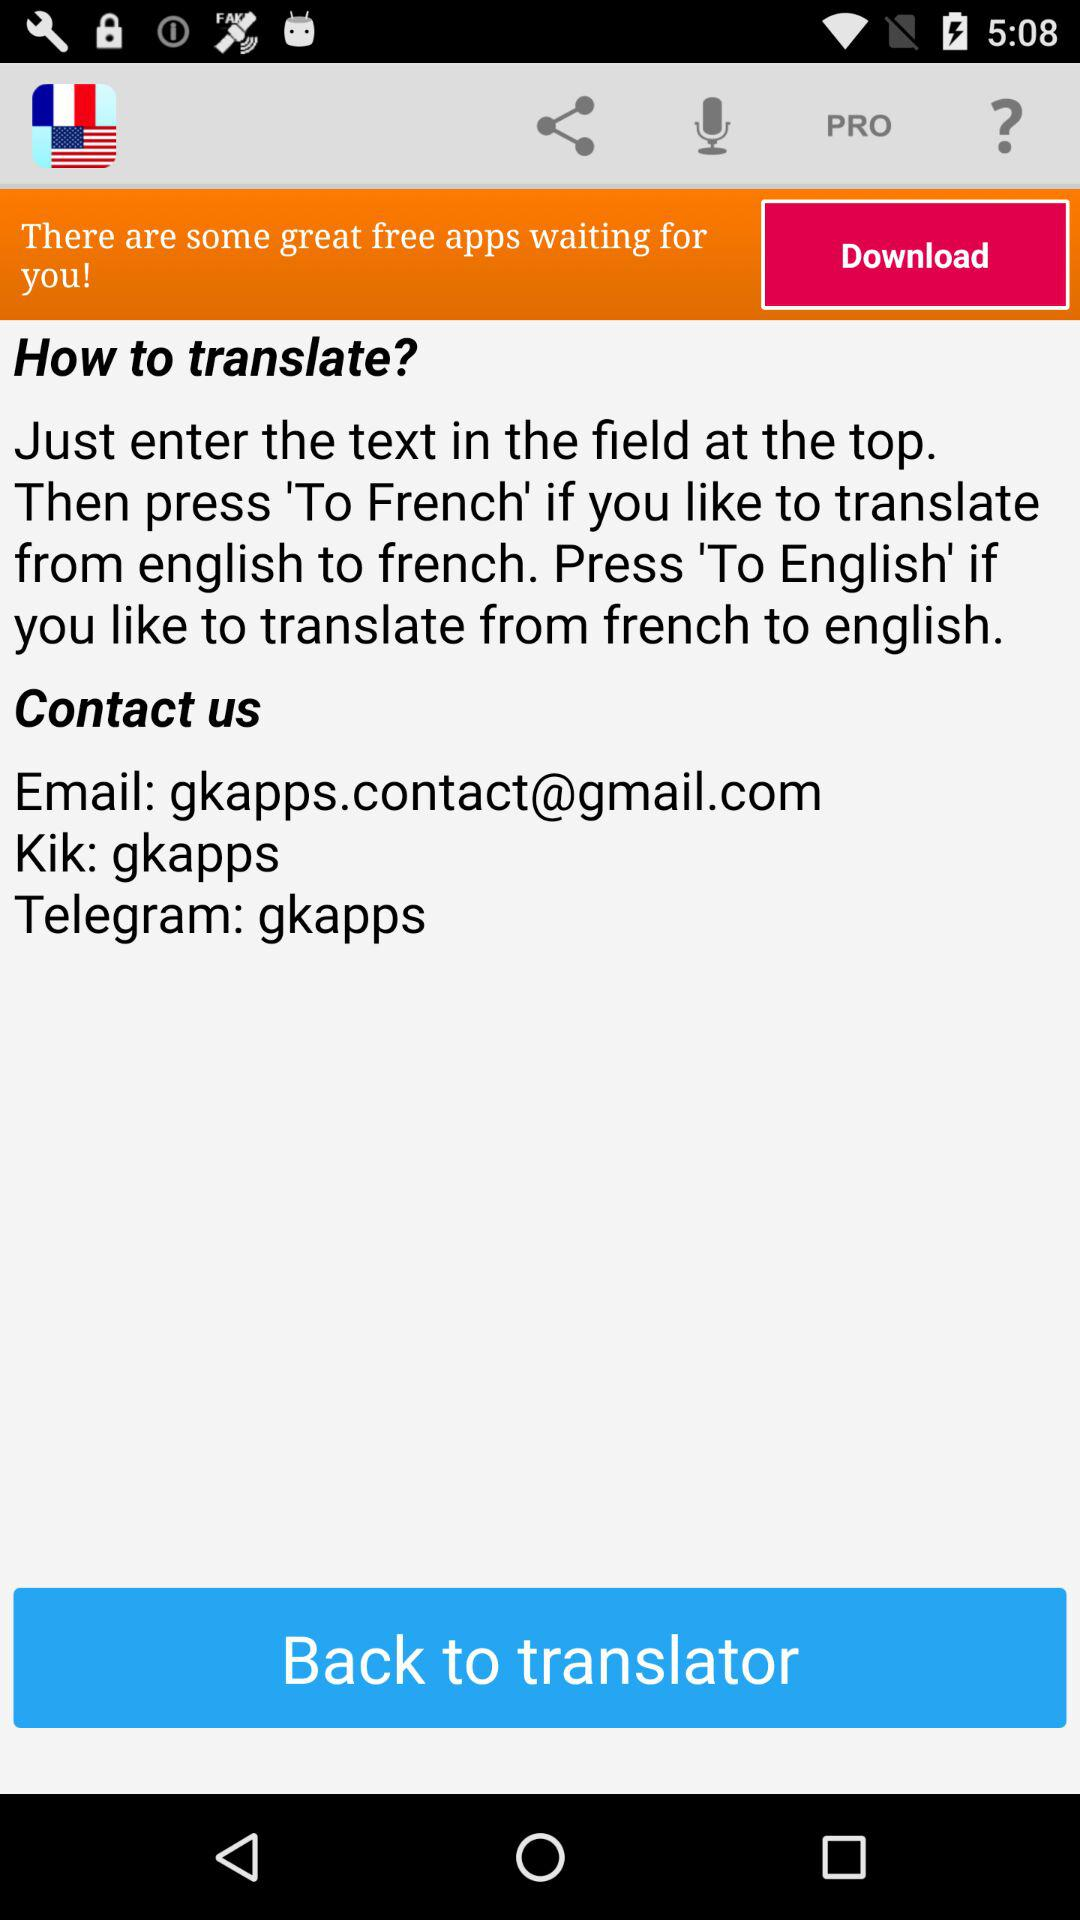What is the username on Telegram? The username is "gkapps". 